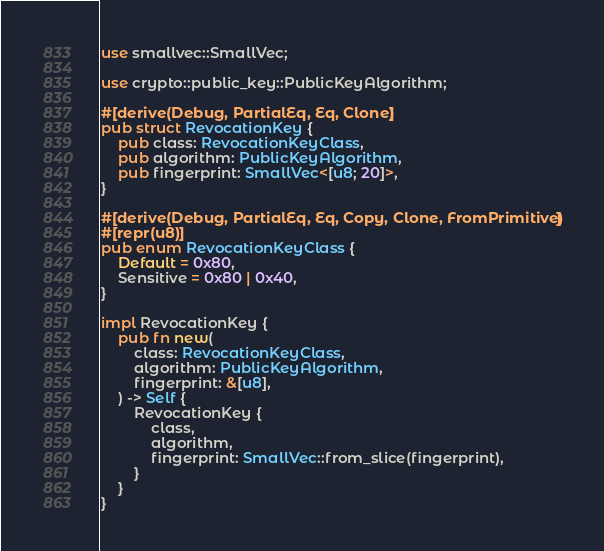Convert code to text. <code><loc_0><loc_0><loc_500><loc_500><_Rust_>use smallvec::SmallVec;

use crypto::public_key::PublicKeyAlgorithm;

#[derive(Debug, PartialEq, Eq, Clone)]
pub struct RevocationKey {
    pub class: RevocationKeyClass,
    pub algorithm: PublicKeyAlgorithm,
    pub fingerprint: SmallVec<[u8; 20]>,
}

#[derive(Debug, PartialEq, Eq, Copy, Clone, FromPrimitive)]
#[repr(u8)]
pub enum RevocationKeyClass {
    Default = 0x80,
    Sensitive = 0x80 | 0x40,
}

impl RevocationKey {
    pub fn new(
        class: RevocationKeyClass,
        algorithm: PublicKeyAlgorithm,
        fingerprint: &[u8],
    ) -> Self {
        RevocationKey {
            class,
            algorithm,
            fingerprint: SmallVec::from_slice(fingerprint),
        }
    }
}
</code> 